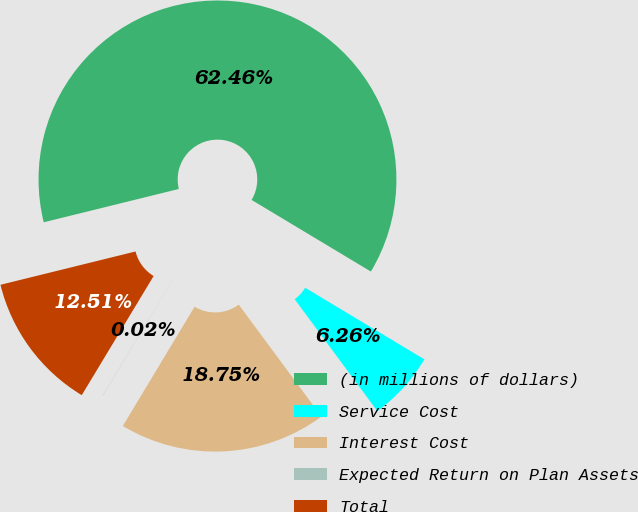Convert chart to OTSL. <chart><loc_0><loc_0><loc_500><loc_500><pie_chart><fcel>(in millions of dollars)<fcel>Service Cost<fcel>Interest Cost<fcel>Expected Return on Plan Assets<fcel>Total<nl><fcel>62.45%<fcel>6.26%<fcel>18.75%<fcel>0.02%<fcel>12.51%<nl></chart> 